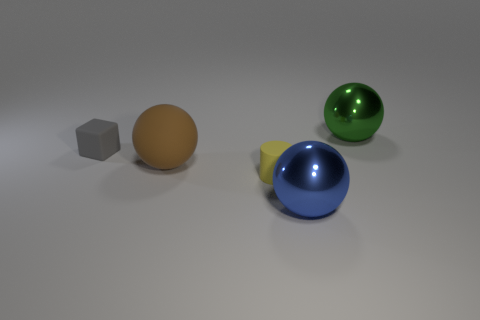What number of cylinders are large metal things or tiny yellow matte objects?
Your answer should be compact. 1. The large object that is to the right of the brown rubber ball and in front of the tiny gray object has what shape?
Your response must be concise. Sphere. Are there the same number of balls that are in front of the big blue thing and tiny yellow matte cylinders that are behind the brown thing?
Provide a succinct answer. Yes. What number of things are big brown rubber spheres or small brown shiny objects?
Your answer should be very brief. 1. What color is the matte block that is the same size as the yellow rubber object?
Your response must be concise. Gray. What number of objects are big balls behind the big blue metal sphere or big spheres that are right of the brown sphere?
Provide a short and direct response. 3. Is the number of tiny rubber things that are in front of the large brown thing the same as the number of big green metallic things?
Ensure brevity in your answer.  Yes. There is a metallic ball that is to the left of the big green metallic ball; is it the same size as the thing that is on the right side of the blue metallic sphere?
Keep it short and to the point. Yes. How many other objects are there of the same size as the cylinder?
Your response must be concise. 1. There is a object that is right of the big metal sphere in front of the big green sphere; is there a rubber sphere left of it?
Ensure brevity in your answer.  Yes. 